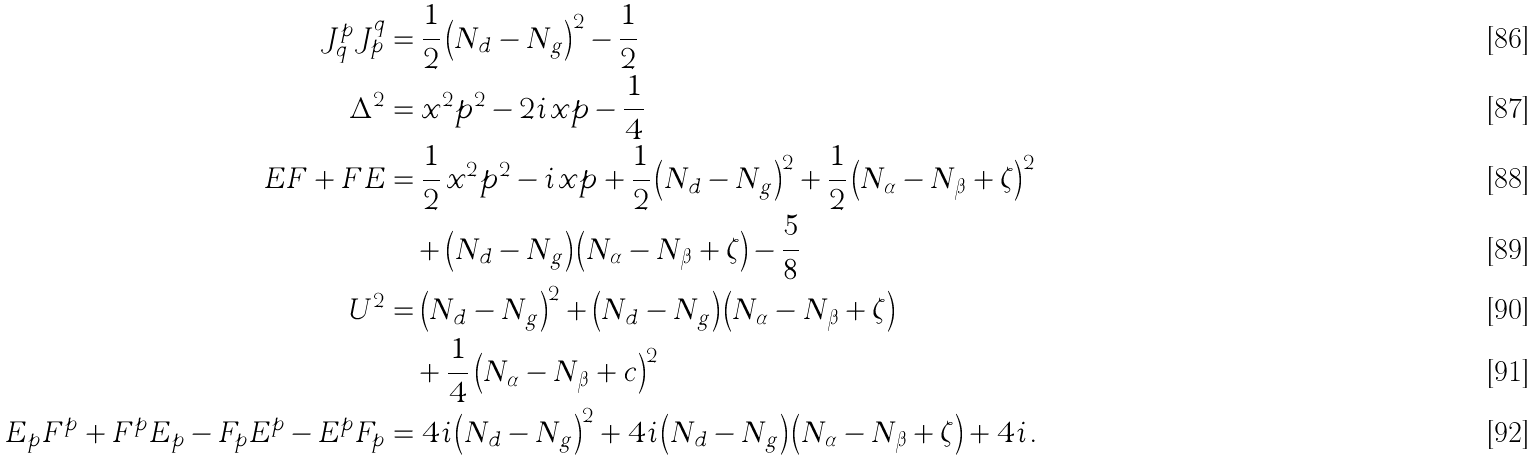Convert formula to latex. <formula><loc_0><loc_0><loc_500><loc_500>J ^ { p } _ { q } J ^ { q } _ { p } & = \frac { 1 } { 2 } \left ( N _ { d } - N _ { g } \right ) ^ { 2 } - \frac { 1 } { 2 } \\ \Delta ^ { 2 } & = x ^ { 2 } p ^ { 2 } - 2 i \, x p - \frac { 1 } { 4 } \\ E F + F E & = \frac { 1 } { 2 } \, x ^ { 2 } p ^ { 2 } - i \, x p + \frac { 1 } { 2 } \left ( N _ { d } - N _ { g } \right ) ^ { 2 } + \frac { 1 } { 2 } \left ( N _ { \alpha } - N _ { \beta } + \zeta \right ) ^ { 2 } \\ & \quad + \left ( N _ { d } - N _ { g } \right ) \left ( N _ { \alpha } - N _ { \beta } + \zeta \right ) - \frac { 5 } { 8 } \\ U ^ { 2 } & = \left ( N _ { d } - N _ { g } \right ) ^ { 2 } + \left ( N _ { d } - N _ { g } \right ) \left ( N _ { \alpha } - N _ { \beta } + \zeta \right ) \\ & \quad + \frac { 1 } { 4 } \left ( N _ { \alpha } - N _ { \beta } + c \right ) ^ { 2 } \\ E _ { p } F ^ { p } + F ^ { p } E _ { p } - F _ { p } E ^ { p } - E ^ { p } F _ { p } & = 4 i \left ( N _ { d } - N _ { g } \right ) ^ { 2 } + 4 i \left ( N _ { d } - N _ { g } \right ) \left ( N _ { \alpha } - N _ { \beta } + \zeta \right ) + 4 i \, .</formula> 